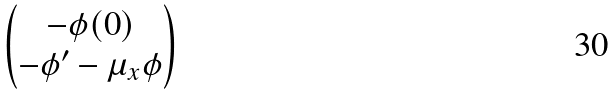Convert formula to latex. <formula><loc_0><loc_0><loc_500><loc_500>\begin{pmatrix} - \phi ( 0 ) \\ - \phi ^ { \prime } - \mu _ { x } \phi \end{pmatrix}</formula> 